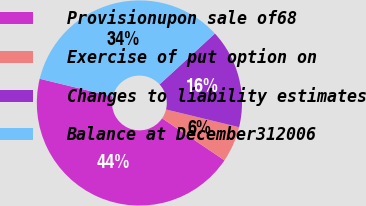<chart> <loc_0><loc_0><loc_500><loc_500><pie_chart><fcel>Provisionupon sale of68<fcel>Exercise of put option on<fcel>Changes to liability estimates<fcel>Balance at December312006<nl><fcel>44.35%<fcel>5.65%<fcel>15.63%<fcel>34.37%<nl></chart> 